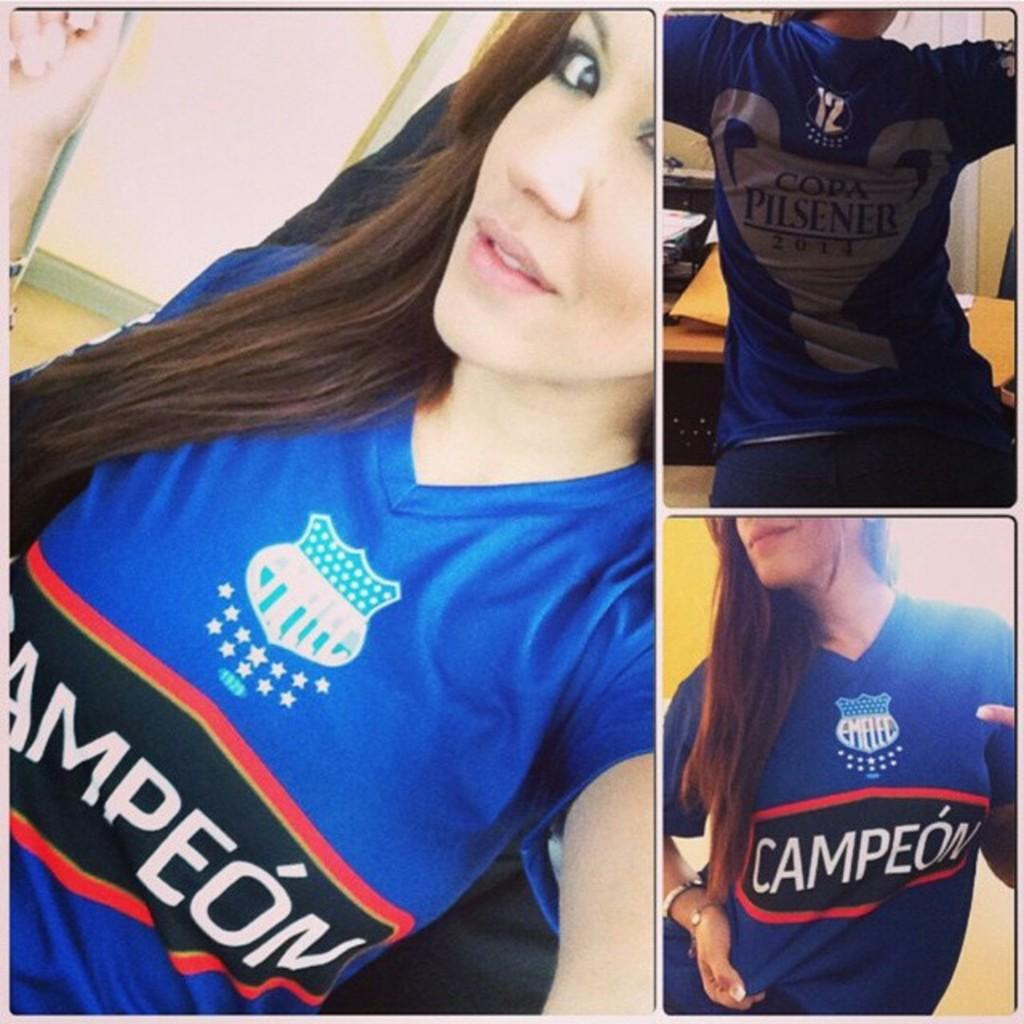<image>
Create a compact narrative representing the image presented. The girl shows off a sports top with the word Campeon written on it. 